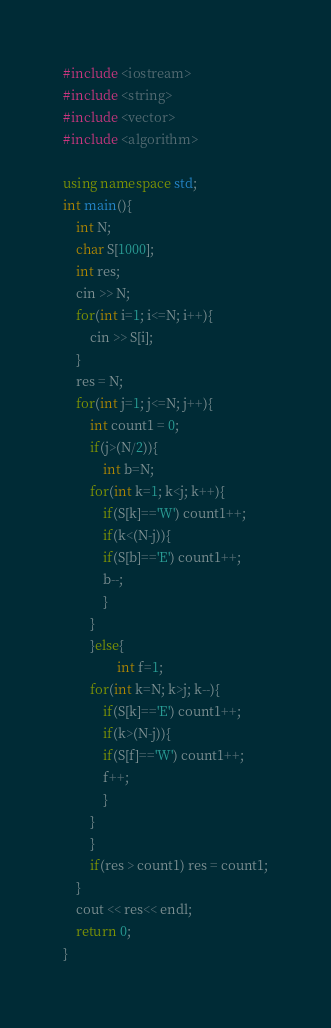Convert code to text. <code><loc_0><loc_0><loc_500><loc_500><_C++_>#include <iostream>
#include <string>
#include <vector>
#include <algorithm>

using namespace std;
int main(){
	int N;
	char S[1000];
	int res;
	cin >> N;
	for(int i=1; i<=N; i++){
		cin >> S[i];
	}
	res = N;
	for(int j=1; j<=N; j++){
		int count1 = 0;
        if(j>(N/2)){
			int b=N;
		for(int k=1; k<j; k++){
			if(S[k]=='W') count1++;
			if(k<(N-j)){
			if(S[b]=='E') count1++;
			b--;
			}
		}
		}else{
				int f=1;
		for(int k=N; k>j; k--){
			if(S[k]=='E') count1++;
			if(k>(N-j)){
			if(S[f]=='W') count1++;
			f++;
			}
		}
		}
		if(res > count1) res = count1;
	}
	cout << res<< endl;
	return 0;
}</code> 